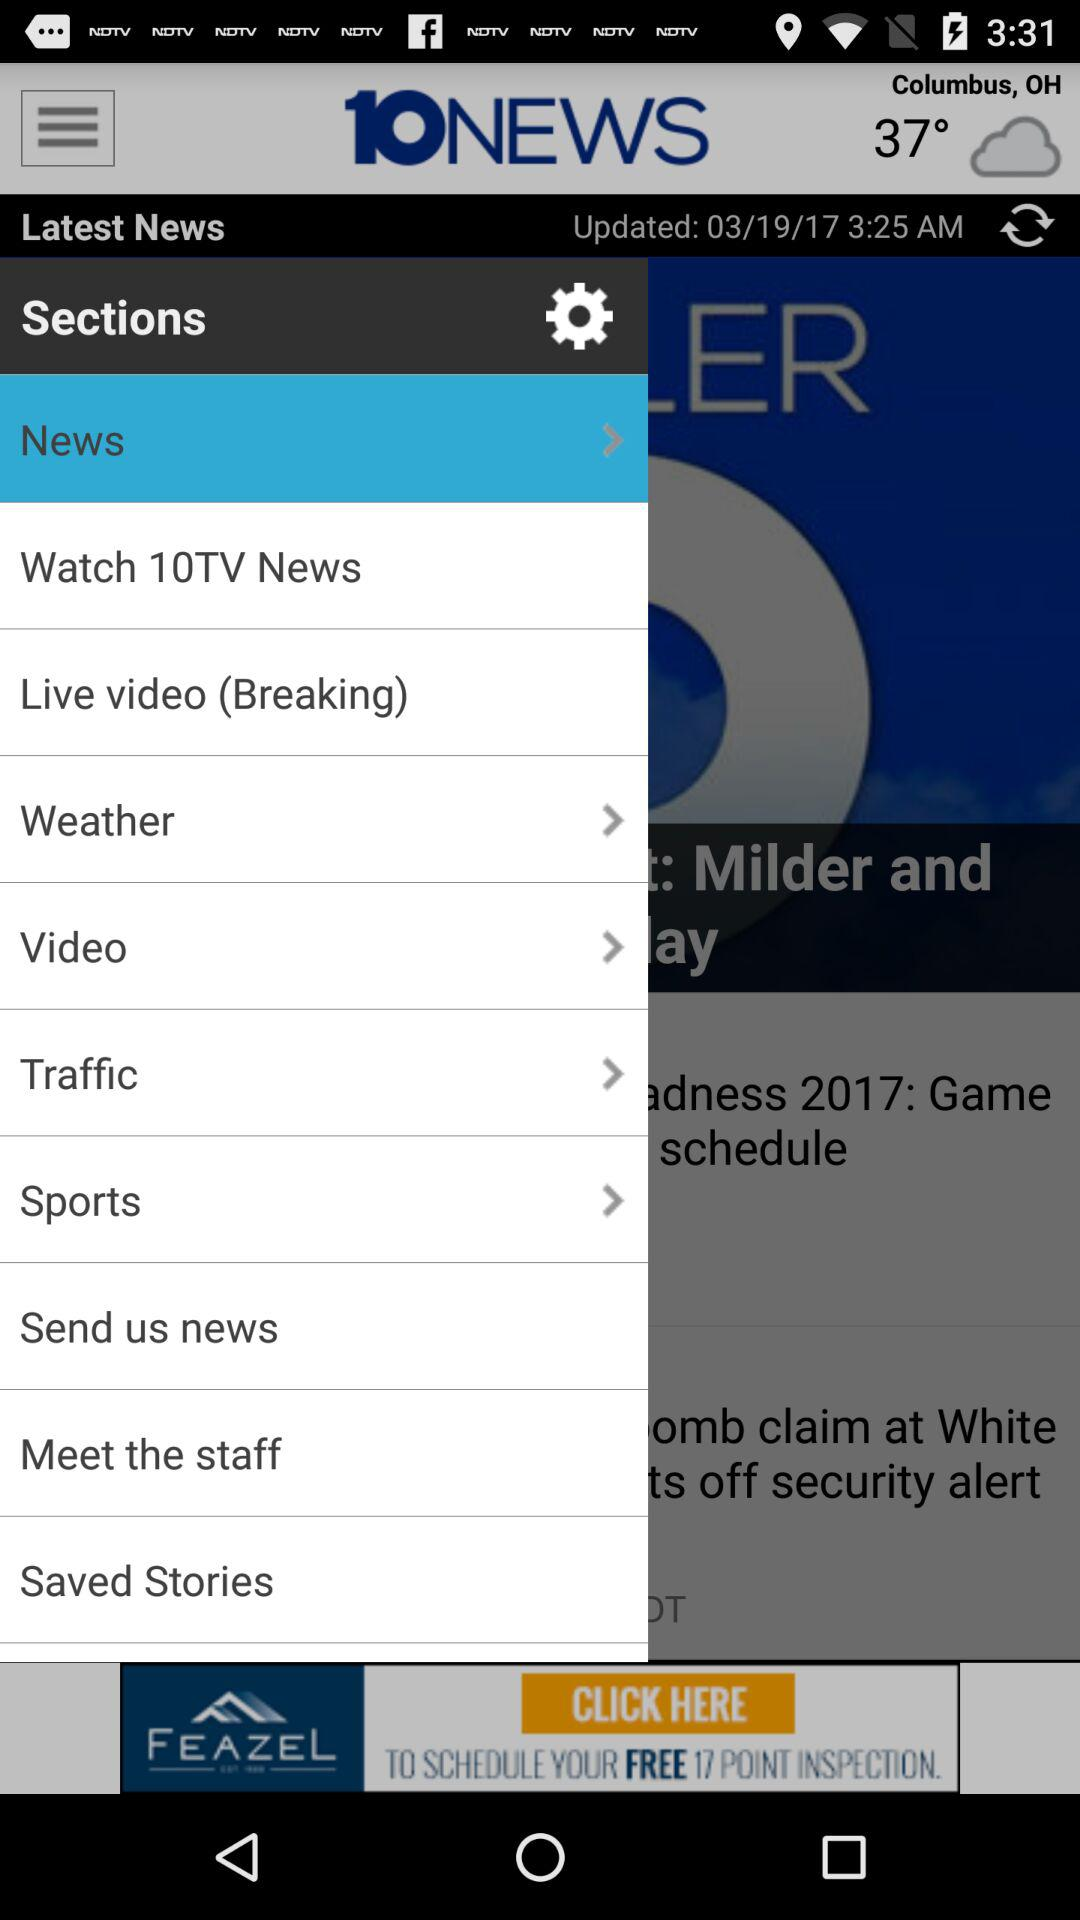Which option is selected under sections? The selected option is "News". 